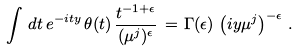<formula> <loc_0><loc_0><loc_500><loc_500>\int \, d t \, e ^ { - i t y } \, \theta ( t ) \, \frac { t ^ { - 1 + \epsilon } } { ( \mu ^ { j } ) ^ { \epsilon } } \, = \, & \, \Gamma ( \epsilon ) \, \left ( i y \mu ^ { j } \right ) ^ { - \epsilon } \, .</formula> 